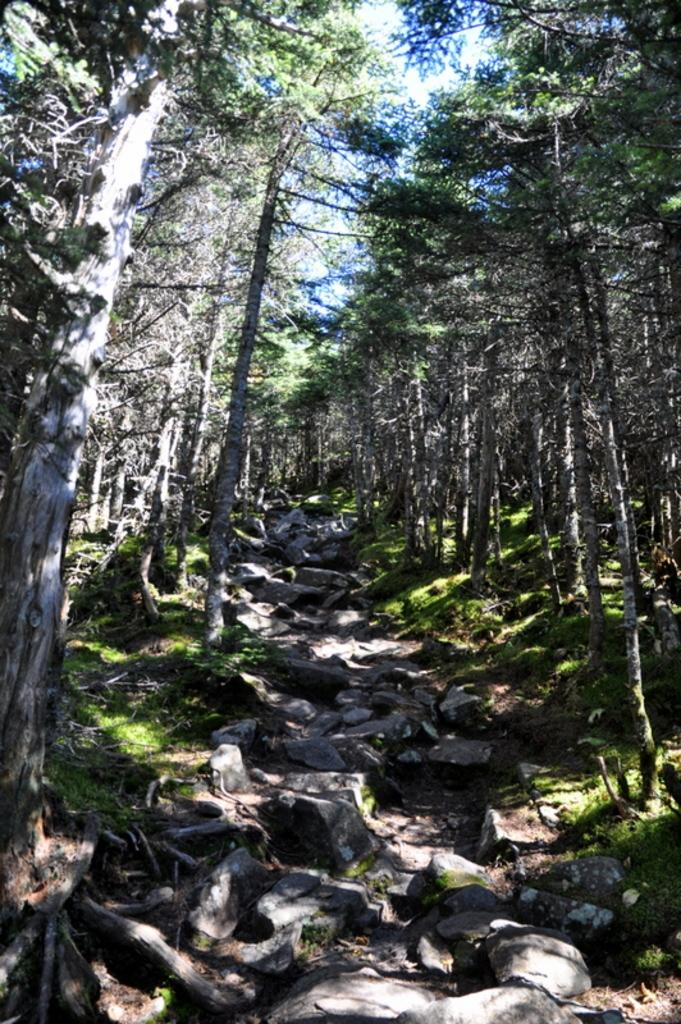What type of vegetation can be seen on both sides of the picture? There are trees on either side of the picture. What type of ground cover is present in the picture? There is grass in the picture. What can be used for walking or traversing in the picture? There is a path at the bottom of the picture. What can be seen in the background of the picture? There are trees in the background of the picture. What flavor of volleyball is being played in the picture? There is no volleyball present in the picture, so it is not possible to determine the flavor of any volleyball being played. How is the control of the trees being managed in the picture? The image does not provide information about managing or controlling the trees; they are simply depicted as part of the natural environment. 